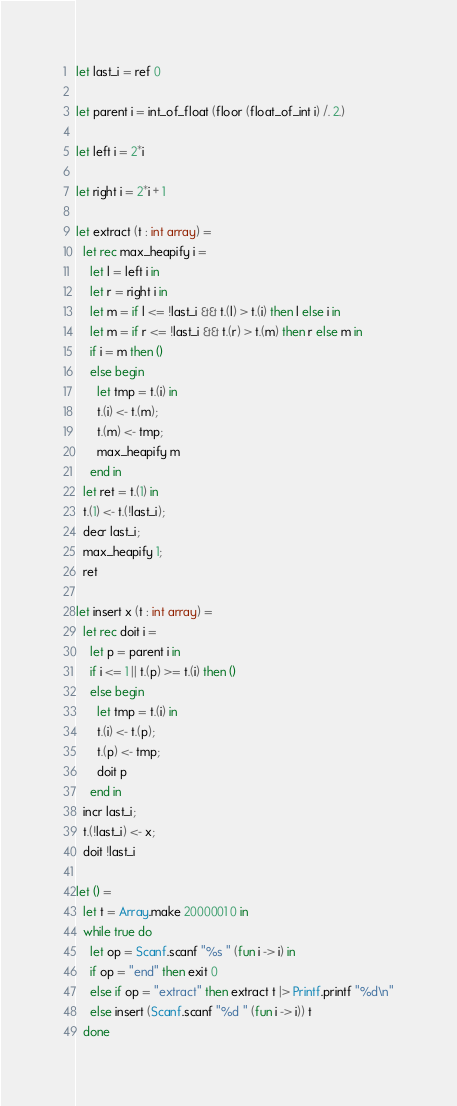<code> <loc_0><loc_0><loc_500><loc_500><_OCaml_>let last_i = ref 0

let parent i = int_of_float (floor (float_of_int i) /. 2.)

let left i = 2*i

let right i = 2*i + 1

let extract (t : int array) =
  let rec max_heapify i =
    let l = left i in
    let r = right i in
    let m = if l <= !last_i && t.(l) > t.(i) then l else i in
    let m = if r <= !last_i && t.(r) > t.(m) then r else m in
    if i = m then ()
    else begin
      let tmp = t.(i) in
      t.(i) <- t.(m);
      t.(m) <- tmp;
      max_heapify m
    end in
  let ret = t.(1) in
  t.(1) <- t.(!last_i);
  decr last_i;
  max_heapify 1;
  ret

let insert x (t : int array) =
  let rec doit i =
    let p = parent i in
    if i <= 1 || t.(p) >= t.(i) then ()
    else begin
      let tmp = t.(i) in
      t.(i) <- t.(p);
      t.(p) <- tmp;
      doit p
    end in
  incr last_i;
  t.(!last_i) <- x;
  doit !last_i

let () =
  let t = Array.make 2000001 0 in
  while true do
    let op = Scanf.scanf "%s " (fun i -> i) in
    if op = "end" then exit 0
    else if op = "extract" then extract t |> Printf.printf "%d\n"
    else insert (Scanf.scanf "%d " (fun i -> i)) t
  done</code> 